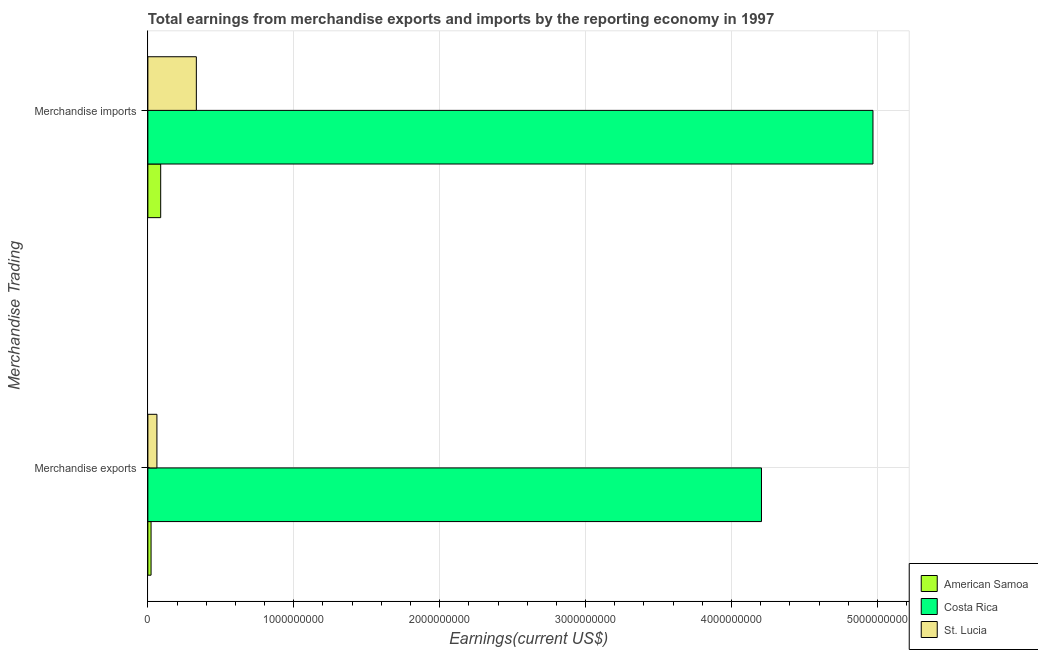How many different coloured bars are there?
Offer a terse response. 3. How many groups of bars are there?
Offer a terse response. 2. How many bars are there on the 2nd tick from the top?
Provide a succinct answer. 3. How many bars are there on the 2nd tick from the bottom?
Your answer should be compact. 3. What is the label of the 1st group of bars from the top?
Ensure brevity in your answer.  Merchandise imports. What is the earnings from merchandise imports in St. Lucia?
Ensure brevity in your answer.  3.32e+08. Across all countries, what is the maximum earnings from merchandise exports?
Provide a short and direct response. 4.21e+09. Across all countries, what is the minimum earnings from merchandise imports?
Offer a very short reply. 8.79e+07. In which country was the earnings from merchandise imports minimum?
Your response must be concise. American Samoa. What is the total earnings from merchandise imports in the graph?
Offer a very short reply. 5.39e+09. What is the difference between the earnings from merchandise imports in St. Lucia and that in Costa Rica?
Your answer should be very brief. -4.64e+09. What is the difference between the earnings from merchandise imports in Costa Rica and the earnings from merchandise exports in St. Lucia?
Make the answer very short. 4.91e+09. What is the average earnings from merchandise exports per country?
Give a very brief answer. 1.43e+09. What is the difference between the earnings from merchandise imports and earnings from merchandise exports in American Samoa?
Your answer should be compact. 6.60e+07. In how many countries, is the earnings from merchandise exports greater than 1600000000 US$?
Provide a short and direct response. 1. What is the ratio of the earnings from merchandise imports in Costa Rica to that in St. Lucia?
Offer a terse response. 14.96. Is the earnings from merchandise exports in St. Lucia less than that in American Samoa?
Make the answer very short. No. What does the 1st bar from the top in Merchandise exports represents?
Provide a succinct answer. St. Lucia. What does the 2nd bar from the bottom in Merchandise exports represents?
Your answer should be very brief. Costa Rica. How many bars are there?
Keep it short and to the point. 6. How many countries are there in the graph?
Provide a short and direct response. 3. What is the difference between two consecutive major ticks on the X-axis?
Your answer should be compact. 1.00e+09. Are the values on the major ticks of X-axis written in scientific E-notation?
Offer a very short reply. No. Where does the legend appear in the graph?
Keep it short and to the point. Bottom right. How many legend labels are there?
Provide a succinct answer. 3. What is the title of the graph?
Keep it short and to the point. Total earnings from merchandise exports and imports by the reporting economy in 1997. What is the label or title of the X-axis?
Your answer should be very brief. Earnings(current US$). What is the label or title of the Y-axis?
Keep it short and to the point. Merchandise Trading. What is the Earnings(current US$) of American Samoa in Merchandise exports?
Offer a very short reply. 2.19e+07. What is the Earnings(current US$) in Costa Rica in Merchandise exports?
Your response must be concise. 4.21e+09. What is the Earnings(current US$) in St. Lucia in Merchandise exports?
Your response must be concise. 6.20e+07. What is the Earnings(current US$) of American Samoa in Merchandise imports?
Make the answer very short. 8.79e+07. What is the Earnings(current US$) in Costa Rica in Merchandise imports?
Offer a very short reply. 4.97e+09. What is the Earnings(current US$) of St. Lucia in Merchandise imports?
Offer a terse response. 3.32e+08. Across all Merchandise Trading, what is the maximum Earnings(current US$) in American Samoa?
Provide a succinct answer. 8.79e+07. Across all Merchandise Trading, what is the maximum Earnings(current US$) in Costa Rica?
Keep it short and to the point. 4.97e+09. Across all Merchandise Trading, what is the maximum Earnings(current US$) in St. Lucia?
Your answer should be compact. 3.32e+08. Across all Merchandise Trading, what is the minimum Earnings(current US$) of American Samoa?
Your answer should be very brief. 2.19e+07. Across all Merchandise Trading, what is the minimum Earnings(current US$) in Costa Rica?
Offer a terse response. 4.21e+09. Across all Merchandise Trading, what is the minimum Earnings(current US$) in St. Lucia?
Keep it short and to the point. 6.20e+07. What is the total Earnings(current US$) in American Samoa in the graph?
Offer a very short reply. 1.10e+08. What is the total Earnings(current US$) of Costa Rica in the graph?
Make the answer very short. 9.18e+09. What is the total Earnings(current US$) in St. Lucia in the graph?
Your response must be concise. 3.94e+08. What is the difference between the Earnings(current US$) of American Samoa in Merchandise exports and that in Merchandise imports?
Give a very brief answer. -6.60e+07. What is the difference between the Earnings(current US$) in Costa Rica in Merchandise exports and that in Merchandise imports?
Provide a succinct answer. -7.64e+08. What is the difference between the Earnings(current US$) of St. Lucia in Merchandise exports and that in Merchandise imports?
Your answer should be compact. -2.70e+08. What is the difference between the Earnings(current US$) in American Samoa in Merchandise exports and the Earnings(current US$) in Costa Rica in Merchandise imports?
Provide a succinct answer. -4.95e+09. What is the difference between the Earnings(current US$) of American Samoa in Merchandise exports and the Earnings(current US$) of St. Lucia in Merchandise imports?
Offer a very short reply. -3.10e+08. What is the difference between the Earnings(current US$) in Costa Rica in Merchandise exports and the Earnings(current US$) in St. Lucia in Merchandise imports?
Ensure brevity in your answer.  3.87e+09. What is the average Earnings(current US$) in American Samoa per Merchandise Trading?
Give a very brief answer. 5.49e+07. What is the average Earnings(current US$) of Costa Rica per Merchandise Trading?
Keep it short and to the point. 4.59e+09. What is the average Earnings(current US$) in St. Lucia per Merchandise Trading?
Your answer should be very brief. 1.97e+08. What is the difference between the Earnings(current US$) of American Samoa and Earnings(current US$) of Costa Rica in Merchandise exports?
Offer a very short reply. -4.18e+09. What is the difference between the Earnings(current US$) in American Samoa and Earnings(current US$) in St. Lucia in Merchandise exports?
Provide a short and direct response. -4.01e+07. What is the difference between the Earnings(current US$) in Costa Rica and Earnings(current US$) in St. Lucia in Merchandise exports?
Ensure brevity in your answer.  4.14e+09. What is the difference between the Earnings(current US$) in American Samoa and Earnings(current US$) in Costa Rica in Merchandise imports?
Offer a terse response. -4.88e+09. What is the difference between the Earnings(current US$) of American Samoa and Earnings(current US$) of St. Lucia in Merchandise imports?
Provide a short and direct response. -2.44e+08. What is the difference between the Earnings(current US$) of Costa Rica and Earnings(current US$) of St. Lucia in Merchandise imports?
Offer a very short reply. 4.64e+09. What is the ratio of the Earnings(current US$) in American Samoa in Merchandise exports to that in Merchandise imports?
Keep it short and to the point. 0.25. What is the ratio of the Earnings(current US$) in Costa Rica in Merchandise exports to that in Merchandise imports?
Give a very brief answer. 0.85. What is the ratio of the Earnings(current US$) of St. Lucia in Merchandise exports to that in Merchandise imports?
Make the answer very short. 0.19. What is the difference between the highest and the second highest Earnings(current US$) of American Samoa?
Your answer should be very brief. 6.60e+07. What is the difference between the highest and the second highest Earnings(current US$) in Costa Rica?
Make the answer very short. 7.64e+08. What is the difference between the highest and the second highest Earnings(current US$) in St. Lucia?
Your answer should be compact. 2.70e+08. What is the difference between the highest and the lowest Earnings(current US$) in American Samoa?
Make the answer very short. 6.60e+07. What is the difference between the highest and the lowest Earnings(current US$) in Costa Rica?
Make the answer very short. 7.64e+08. What is the difference between the highest and the lowest Earnings(current US$) in St. Lucia?
Make the answer very short. 2.70e+08. 